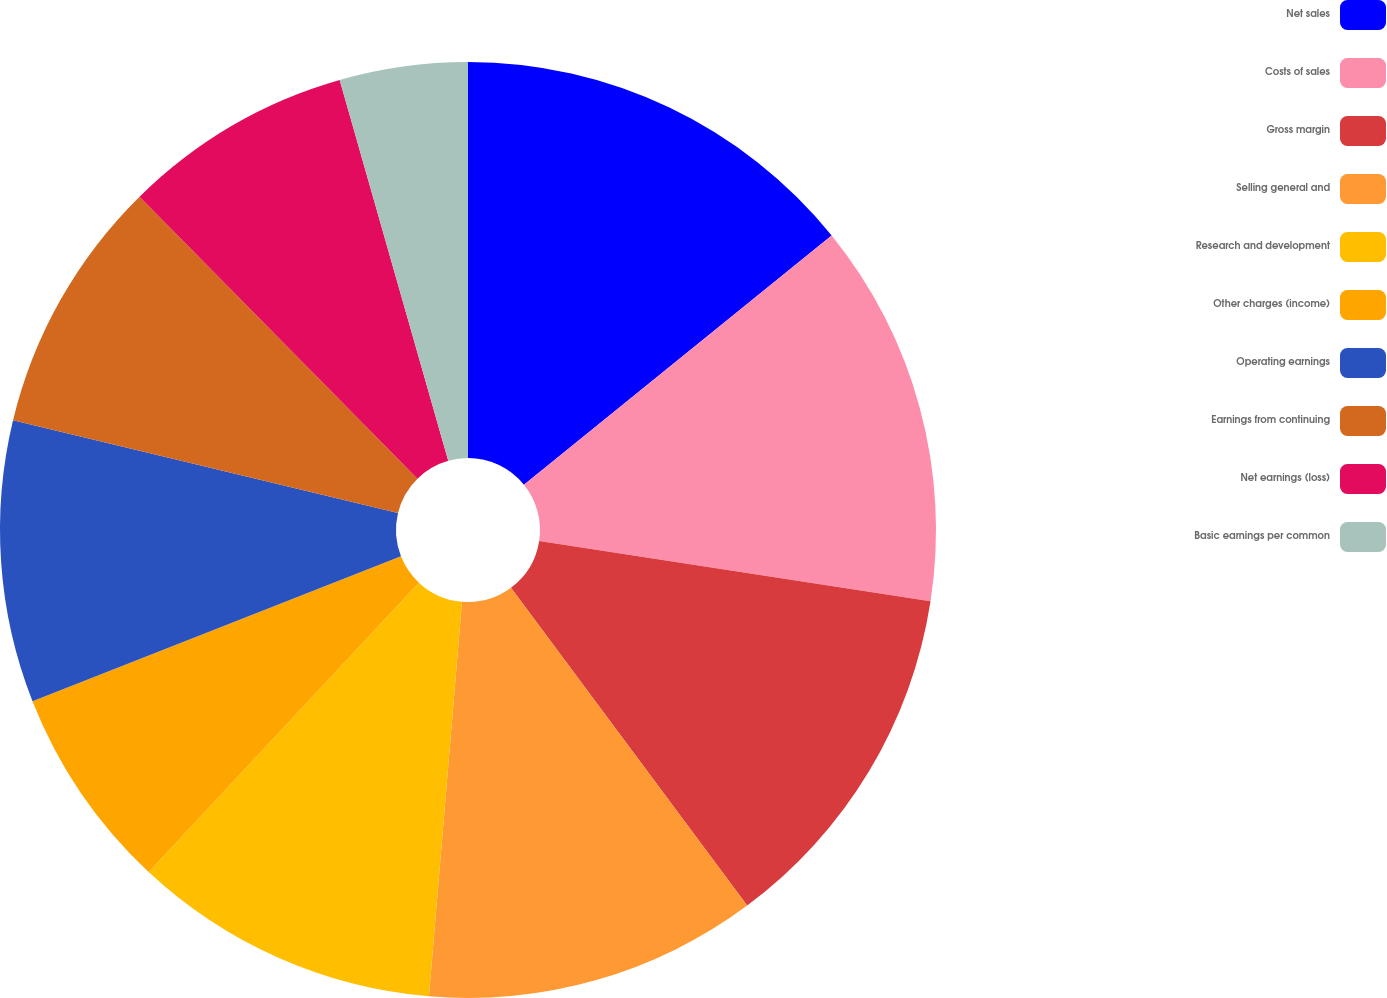Convert chart. <chart><loc_0><loc_0><loc_500><loc_500><pie_chart><fcel>Net sales<fcel>Costs of sales<fcel>Gross margin<fcel>Selling general and<fcel>Research and development<fcel>Other charges (income)<fcel>Operating earnings<fcel>Earnings from continuing<fcel>Net earnings (loss)<fcel>Basic earnings per common<nl><fcel>14.16%<fcel>13.27%<fcel>12.39%<fcel>11.5%<fcel>10.62%<fcel>7.08%<fcel>9.73%<fcel>8.85%<fcel>7.96%<fcel>4.42%<nl></chart> 